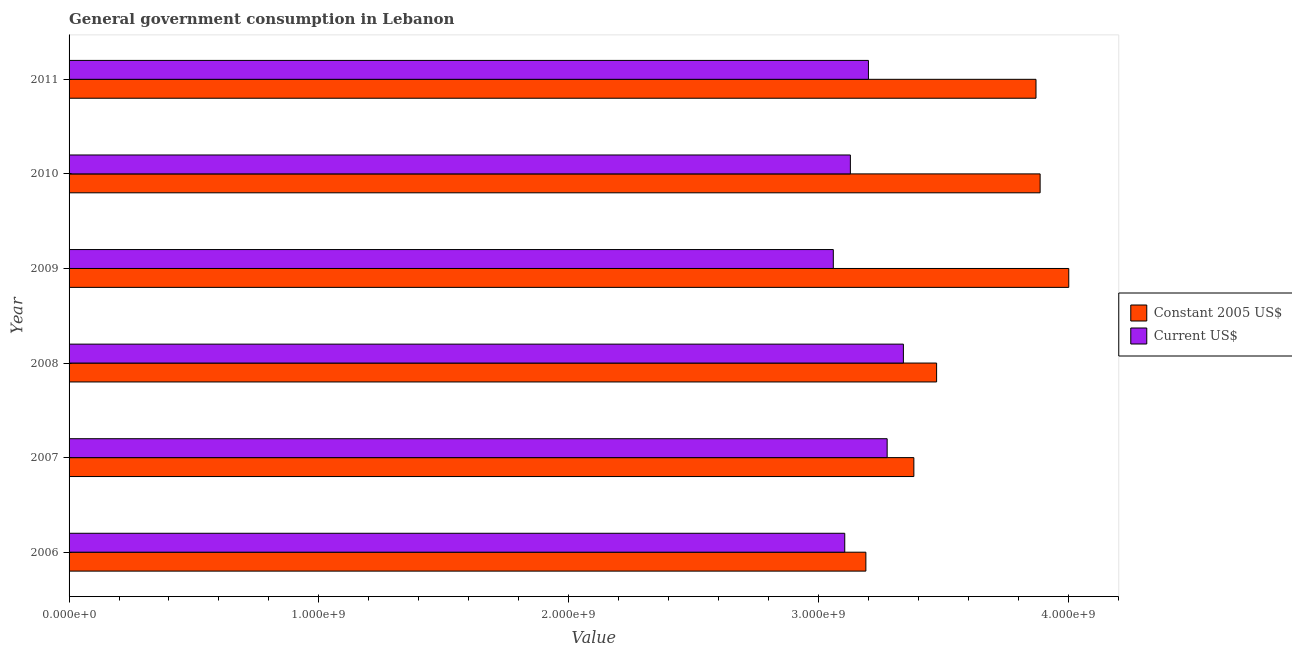How many groups of bars are there?
Ensure brevity in your answer.  6. How many bars are there on the 3rd tick from the bottom?
Offer a very short reply. 2. What is the label of the 2nd group of bars from the top?
Make the answer very short. 2010. In how many cases, is the number of bars for a given year not equal to the number of legend labels?
Provide a short and direct response. 0. What is the value consumed in constant 2005 us$ in 2008?
Provide a short and direct response. 3.47e+09. Across all years, what is the maximum value consumed in constant 2005 us$?
Provide a succinct answer. 4.00e+09. Across all years, what is the minimum value consumed in constant 2005 us$?
Your response must be concise. 3.19e+09. In which year was the value consumed in current us$ maximum?
Your response must be concise. 2008. In which year was the value consumed in current us$ minimum?
Keep it short and to the point. 2009. What is the total value consumed in current us$ in the graph?
Your answer should be very brief. 1.91e+1. What is the difference between the value consumed in current us$ in 2006 and that in 2011?
Give a very brief answer. -9.49e+07. What is the difference between the value consumed in current us$ in 2008 and the value consumed in constant 2005 us$ in 2007?
Ensure brevity in your answer.  -4.19e+07. What is the average value consumed in constant 2005 us$ per year?
Your response must be concise. 3.63e+09. In the year 2006, what is the difference between the value consumed in constant 2005 us$ and value consumed in current us$?
Your response must be concise. 8.46e+07. In how many years, is the value consumed in constant 2005 us$ greater than 3400000000 ?
Provide a short and direct response. 4. What is the ratio of the value consumed in current us$ in 2008 to that in 2009?
Give a very brief answer. 1.09. What is the difference between the highest and the second highest value consumed in current us$?
Your answer should be compact. 6.50e+07. What is the difference between the highest and the lowest value consumed in constant 2005 us$?
Provide a short and direct response. 8.12e+08. What does the 1st bar from the top in 2010 represents?
Offer a terse response. Current US$. What does the 1st bar from the bottom in 2011 represents?
Give a very brief answer. Constant 2005 US$. Are all the bars in the graph horizontal?
Ensure brevity in your answer.  Yes. How many legend labels are there?
Your answer should be compact. 2. How are the legend labels stacked?
Give a very brief answer. Vertical. What is the title of the graph?
Offer a terse response. General government consumption in Lebanon. What is the label or title of the X-axis?
Provide a short and direct response. Value. What is the label or title of the Y-axis?
Give a very brief answer. Year. What is the Value of Constant 2005 US$ in 2006?
Your response must be concise. 3.19e+09. What is the Value of Current US$ in 2006?
Your response must be concise. 3.11e+09. What is the Value of Constant 2005 US$ in 2007?
Give a very brief answer. 3.38e+09. What is the Value of Current US$ in 2007?
Make the answer very short. 3.28e+09. What is the Value in Constant 2005 US$ in 2008?
Provide a short and direct response. 3.47e+09. What is the Value of Current US$ in 2008?
Give a very brief answer. 3.34e+09. What is the Value of Constant 2005 US$ in 2009?
Your answer should be compact. 4.00e+09. What is the Value of Current US$ in 2009?
Offer a very short reply. 3.06e+09. What is the Value in Constant 2005 US$ in 2010?
Ensure brevity in your answer.  3.89e+09. What is the Value of Current US$ in 2010?
Your answer should be compact. 3.13e+09. What is the Value of Constant 2005 US$ in 2011?
Provide a succinct answer. 3.87e+09. What is the Value of Current US$ in 2011?
Your answer should be very brief. 3.20e+09. Across all years, what is the maximum Value in Constant 2005 US$?
Offer a terse response. 4.00e+09. Across all years, what is the maximum Value of Current US$?
Your answer should be very brief. 3.34e+09. Across all years, what is the minimum Value of Constant 2005 US$?
Offer a terse response. 3.19e+09. Across all years, what is the minimum Value in Current US$?
Provide a succinct answer. 3.06e+09. What is the total Value in Constant 2005 US$ in the graph?
Offer a very short reply. 2.18e+1. What is the total Value of Current US$ in the graph?
Provide a short and direct response. 1.91e+1. What is the difference between the Value in Constant 2005 US$ in 2006 and that in 2007?
Keep it short and to the point. -1.92e+08. What is the difference between the Value in Current US$ in 2006 and that in 2007?
Provide a short and direct response. -1.70e+08. What is the difference between the Value of Constant 2005 US$ in 2006 and that in 2008?
Your response must be concise. -2.83e+08. What is the difference between the Value of Current US$ in 2006 and that in 2008?
Your answer should be compact. -2.35e+08. What is the difference between the Value of Constant 2005 US$ in 2006 and that in 2009?
Offer a terse response. -8.12e+08. What is the difference between the Value in Current US$ in 2006 and that in 2009?
Your response must be concise. 4.58e+07. What is the difference between the Value in Constant 2005 US$ in 2006 and that in 2010?
Keep it short and to the point. -6.98e+08. What is the difference between the Value of Current US$ in 2006 and that in 2010?
Ensure brevity in your answer.  -2.26e+07. What is the difference between the Value in Constant 2005 US$ in 2006 and that in 2011?
Offer a terse response. -6.81e+08. What is the difference between the Value in Current US$ in 2006 and that in 2011?
Your response must be concise. -9.49e+07. What is the difference between the Value in Constant 2005 US$ in 2007 and that in 2008?
Ensure brevity in your answer.  -9.11e+07. What is the difference between the Value in Current US$ in 2007 and that in 2008?
Provide a succinct answer. -6.50e+07. What is the difference between the Value of Constant 2005 US$ in 2007 and that in 2009?
Provide a short and direct response. -6.20e+08. What is the difference between the Value of Current US$ in 2007 and that in 2009?
Your answer should be compact. 2.16e+08. What is the difference between the Value of Constant 2005 US$ in 2007 and that in 2010?
Offer a terse response. -5.06e+08. What is the difference between the Value in Current US$ in 2007 and that in 2010?
Your answer should be very brief. 1.47e+08. What is the difference between the Value of Constant 2005 US$ in 2007 and that in 2011?
Offer a terse response. -4.89e+08. What is the difference between the Value in Current US$ in 2007 and that in 2011?
Offer a very short reply. 7.50e+07. What is the difference between the Value of Constant 2005 US$ in 2008 and that in 2009?
Ensure brevity in your answer.  -5.29e+08. What is the difference between the Value in Current US$ in 2008 and that in 2009?
Your answer should be very brief. 2.81e+08. What is the difference between the Value of Constant 2005 US$ in 2008 and that in 2010?
Your answer should be very brief. -4.14e+08. What is the difference between the Value in Current US$ in 2008 and that in 2010?
Your answer should be compact. 2.12e+08. What is the difference between the Value in Constant 2005 US$ in 2008 and that in 2011?
Provide a short and direct response. -3.98e+08. What is the difference between the Value in Current US$ in 2008 and that in 2011?
Offer a terse response. 1.40e+08. What is the difference between the Value in Constant 2005 US$ in 2009 and that in 2010?
Provide a succinct answer. 1.15e+08. What is the difference between the Value in Current US$ in 2009 and that in 2010?
Your answer should be compact. -6.83e+07. What is the difference between the Value in Constant 2005 US$ in 2009 and that in 2011?
Give a very brief answer. 1.31e+08. What is the difference between the Value in Current US$ in 2009 and that in 2011?
Your answer should be very brief. -1.41e+08. What is the difference between the Value in Constant 2005 US$ in 2010 and that in 2011?
Your answer should be very brief. 1.65e+07. What is the difference between the Value of Current US$ in 2010 and that in 2011?
Your response must be concise. -7.23e+07. What is the difference between the Value of Constant 2005 US$ in 2006 and the Value of Current US$ in 2007?
Offer a terse response. -8.52e+07. What is the difference between the Value of Constant 2005 US$ in 2006 and the Value of Current US$ in 2008?
Offer a very short reply. -1.50e+08. What is the difference between the Value in Constant 2005 US$ in 2006 and the Value in Current US$ in 2009?
Make the answer very short. 1.30e+08. What is the difference between the Value of Constant 2005 US$ in 2006 and the Value of Current US$ in 2010?
Your response must be concise. 6.20e+07. What is the difference between the Value in Constant 2005 US$ in 2006 and the Value in Current US$ in 2011?
Offer a very short reply. -1.03e+07. What is the difference between the Value in Constant 2005 US$ in 2007 and the Value in Current US$ in 2008?
Provide a short and direct response. 4.19e+07. What is the difference between the Value in Constant 2005 US$ in 2007 and the Value in Current US$ in 2009?
Keep it short and to the point. 3.22e+08. What is the difference between the Value in Constant 2005 US$ in 2007 and the Value in Current US$ in 2010?
Make the answer very short. 2.54e+08. What is the difference between the Value in Constant 2005 US$ in 2007 and the Value in Current US$ in 2011?
Provide a succinct answer. 1.82e+08. What is the difference between the Value of Constant 2005 US$ in 2008 and the Value of Current US$ in 2009?
Provide a succinct answer. 4.14e+08. What is the difference between the Value in Constant 2005 US$ in 2008 and the Value in Current US$ in 2010?
Keep it short and to the point. 3.45e+08. What is the difference between the Value of Constant 2005 US$ in 2008 and the Value of Current US$ in 2011?
Give a very brief answer. 2.73e+08. What is the difference between the Value of Constant 2005 US$ in 2009 and the Value of Current US$ in 2010?
Offer a terse response. 8.74e+08. What is the difference between the Value of Constant 2005 US$ in 2009 and the Value of Current US$ in 2011?
Offer a very short reply. 8.02e+08. What is the difference between the Value of Constant 2005 US$ in 2010 and the Value of Current US$ in 2011?
Your answer should be very brief. 6.87e+08. What is the average Value in Constant 2005 US$ per year?
Your answer should be very brief. 3.63e+09. What is the average Value in Current US$ per year?
Keep it short and to the point. 3.19e+09. In the year 2006, what is the difference between the Value of Constant 2005 US$ and Value of Current US$?
Offer a very short reply. 8.46e+07. In the year 2007, what is the difference between the Value of Constant 2005 US$ and Value of Current US$?
Ensure brevity in your answer.  1.07e+08. In the year 2008, what is the difference between the Value of Constant 2005 US$ and Value of Current US$?
Ensure brevity in your answer.  1.33e+08. In the year 2009, what is the difference between the Value of Constant 2005 US$ and Value of Current US$?
Your response must be concise. 9.43e+08. In the year 2010, what is the difference between the Value in Constant 2005 US$ and Value in Current US$?
Ensure brevity in your answer.  7.60e+08. In the year 2011, what is the difference between the Value in Constant 2005 US$ and Value in Current US$?
Provide a short and direct response. 6.71e+08. What is the ratio of the Value of Constant 2005 US$ in 2006 to that in 2007?
Your response must be concise. 0.94. What is the ratio of the Value of Current US$ in 2006 to that in 2007?
Provide a succinct answer. 0.95. What is the ratio of the Value in Constant 2005 US$ in 2006 to that in 2008?
Your response must be concise. 0.92. What is the ratio of the Value of Current US$ in 2006 to that in 2008?
Give a very brief answer. 0.93. What is the ratio of the Value of Constant 2005 US$ in 2006 to that in 2009?
Keep it short and to the point. 0.8. What is the ratio of the Value in Current US$ in 2006 to that in 2009?
Provide a succinct answer. 1.01. What is the ratio of the Value of Constant 2005 US$ in 2006 to that in 2010?
Offer a terse response. 0.82. What is the ratio of the Value in Constant 2005 US$ in 2006 to that in 2011?
Your answer should be compact. 0.82. What is the ratio of the Value of Current US$ in 2006 to that in 2011?
Your answer should be compact. 0.97. What is the ratio of the Value of Constant 2005 US$ in 2007 to that in 2008?
Give a very brief answer. 0.97. What is the ratio of the Value of Current US$ in 2007 to that in 2008?
Your answer should be compact. 0.98. What is the ratio of the Value of Constant 2005 US$ in 2007 to that in 2009?
Your answer should be very brief. 0.84. What is the ratio of the Value in Current US$ in 2007 to that in 2009?
Give a very brief answer. 1.07. What is the ratio of the Value in Constant 2005 US$ in 2007 to that in 2010?
Your answer should be compact. 0.87. What is the ratio of the Value in Current US$ in 2007 to that in 2010?
Ensure brevity in your answer.  1.05. What is the ratio of the Value in Constant 2005 US$ in 2007 to that in 2011?
Make the answer very short. 0.87. What is the ratio of the Value of Current US$ in 2007 to that in 2011?
Make the answer very short. 1.02. What is the ratio of the Value in Constant 2005 US$ in 2008 to that in 2009?
Make the answer very short. 0.87. What is the ratio of the Value of Current US$ in 2008 to that in 2009?
Give a very brief answer. 1.09. What is the ratio of the Value of Constant 2005 US$ in 2008 to that in 2010?
Offer a terse response. 0.89. What is the ratio of the Value of Current US$ in 2008 to that in 2010?
Your answer should be very brief. 1.07. What is the ratio of the Value in Constant 2005 US$ in 2008 to that in 2011?
Ensure brevity in your answer.  0.9. What is the ratio of the Value in Current US$ in 2008 to that in 2011?
Provide a short and direct response. 1.04. What is the ratio of the Value in Constant 2005 US$ in 2009 to that in 2010?
Provide a short and direct response. 1.03. What is the ratio of the Value in Current US$ in 2009 to that in 2010?
Your answer should be very brief. 0.98. What is the ratio of the Value in Constant 2005 US$ in 2009 to that in 2011?
Provide a succinct answer. 1.03. What is the ratio of the Value of Current US$ in 2009 to that in 2011?
Keep it short and to the point. 0.96. What is the ratio of the Value in Constant 2005 US$ in 2010 to that in 2011?
Your response must be concise. 1. What is the ratio of the Value of Current US$ in 2010 to that in 2011?
Your response must be concise. 0.98. What is the difference between the highest and the second highest Value in Constant 2005 US$?
Offer a very short reply. 1.15e+08. What is the difference between the highest and the second highest Value in Current US$?
Your response must be concise. 6.50e+07. What is the difference between the highest and the lowest Value in Constant 2005 US$?
Offer a very short reply. 8.12e+08. What is the difference between the highest and the lowest Value in Current US$?
Keep it short and to the point. 2.81e+08. 